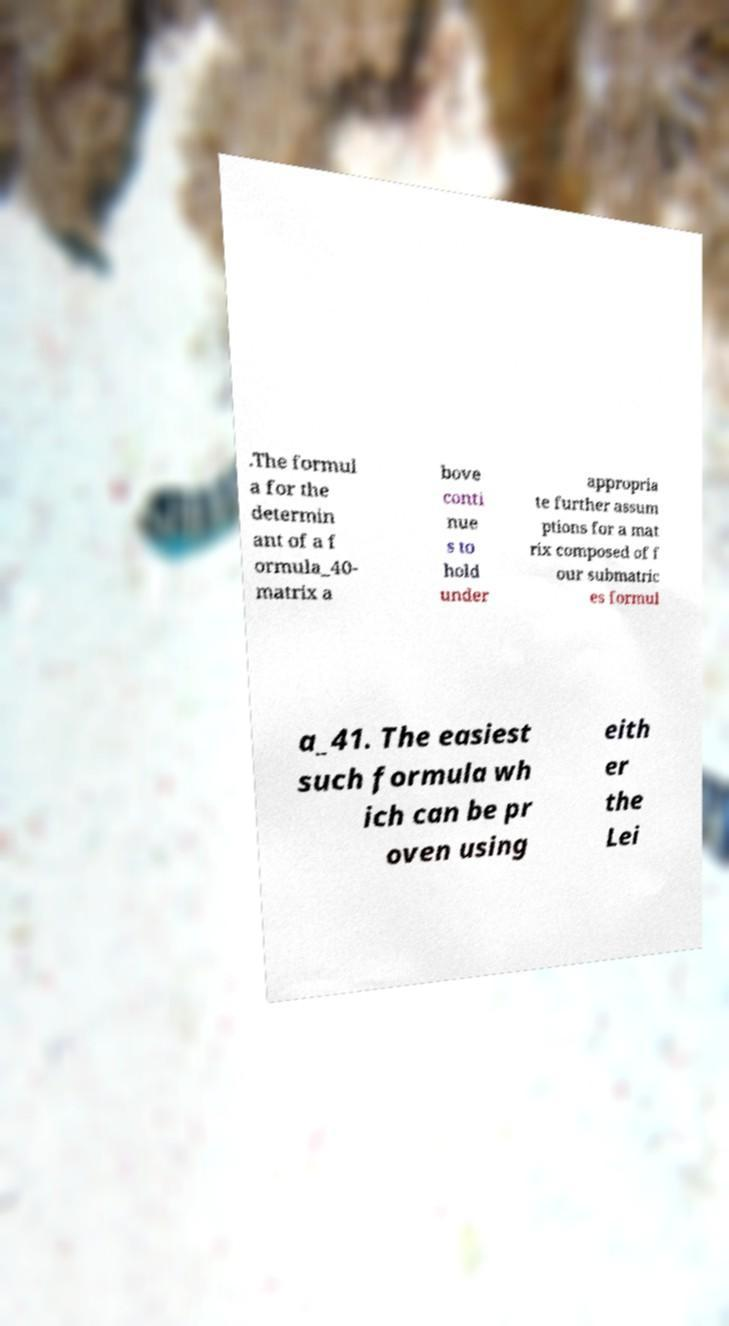I need the written content from this picture converted into text. Can you do that? .The formul a for the determin ant of a f ormula_40- matrix a bove conti nue s to hold under appropria te further assum ptions for a mat rix composed of f our submatric es formul a_41. The easiest such formula wh ich can be pr oven using eith er the Lei 